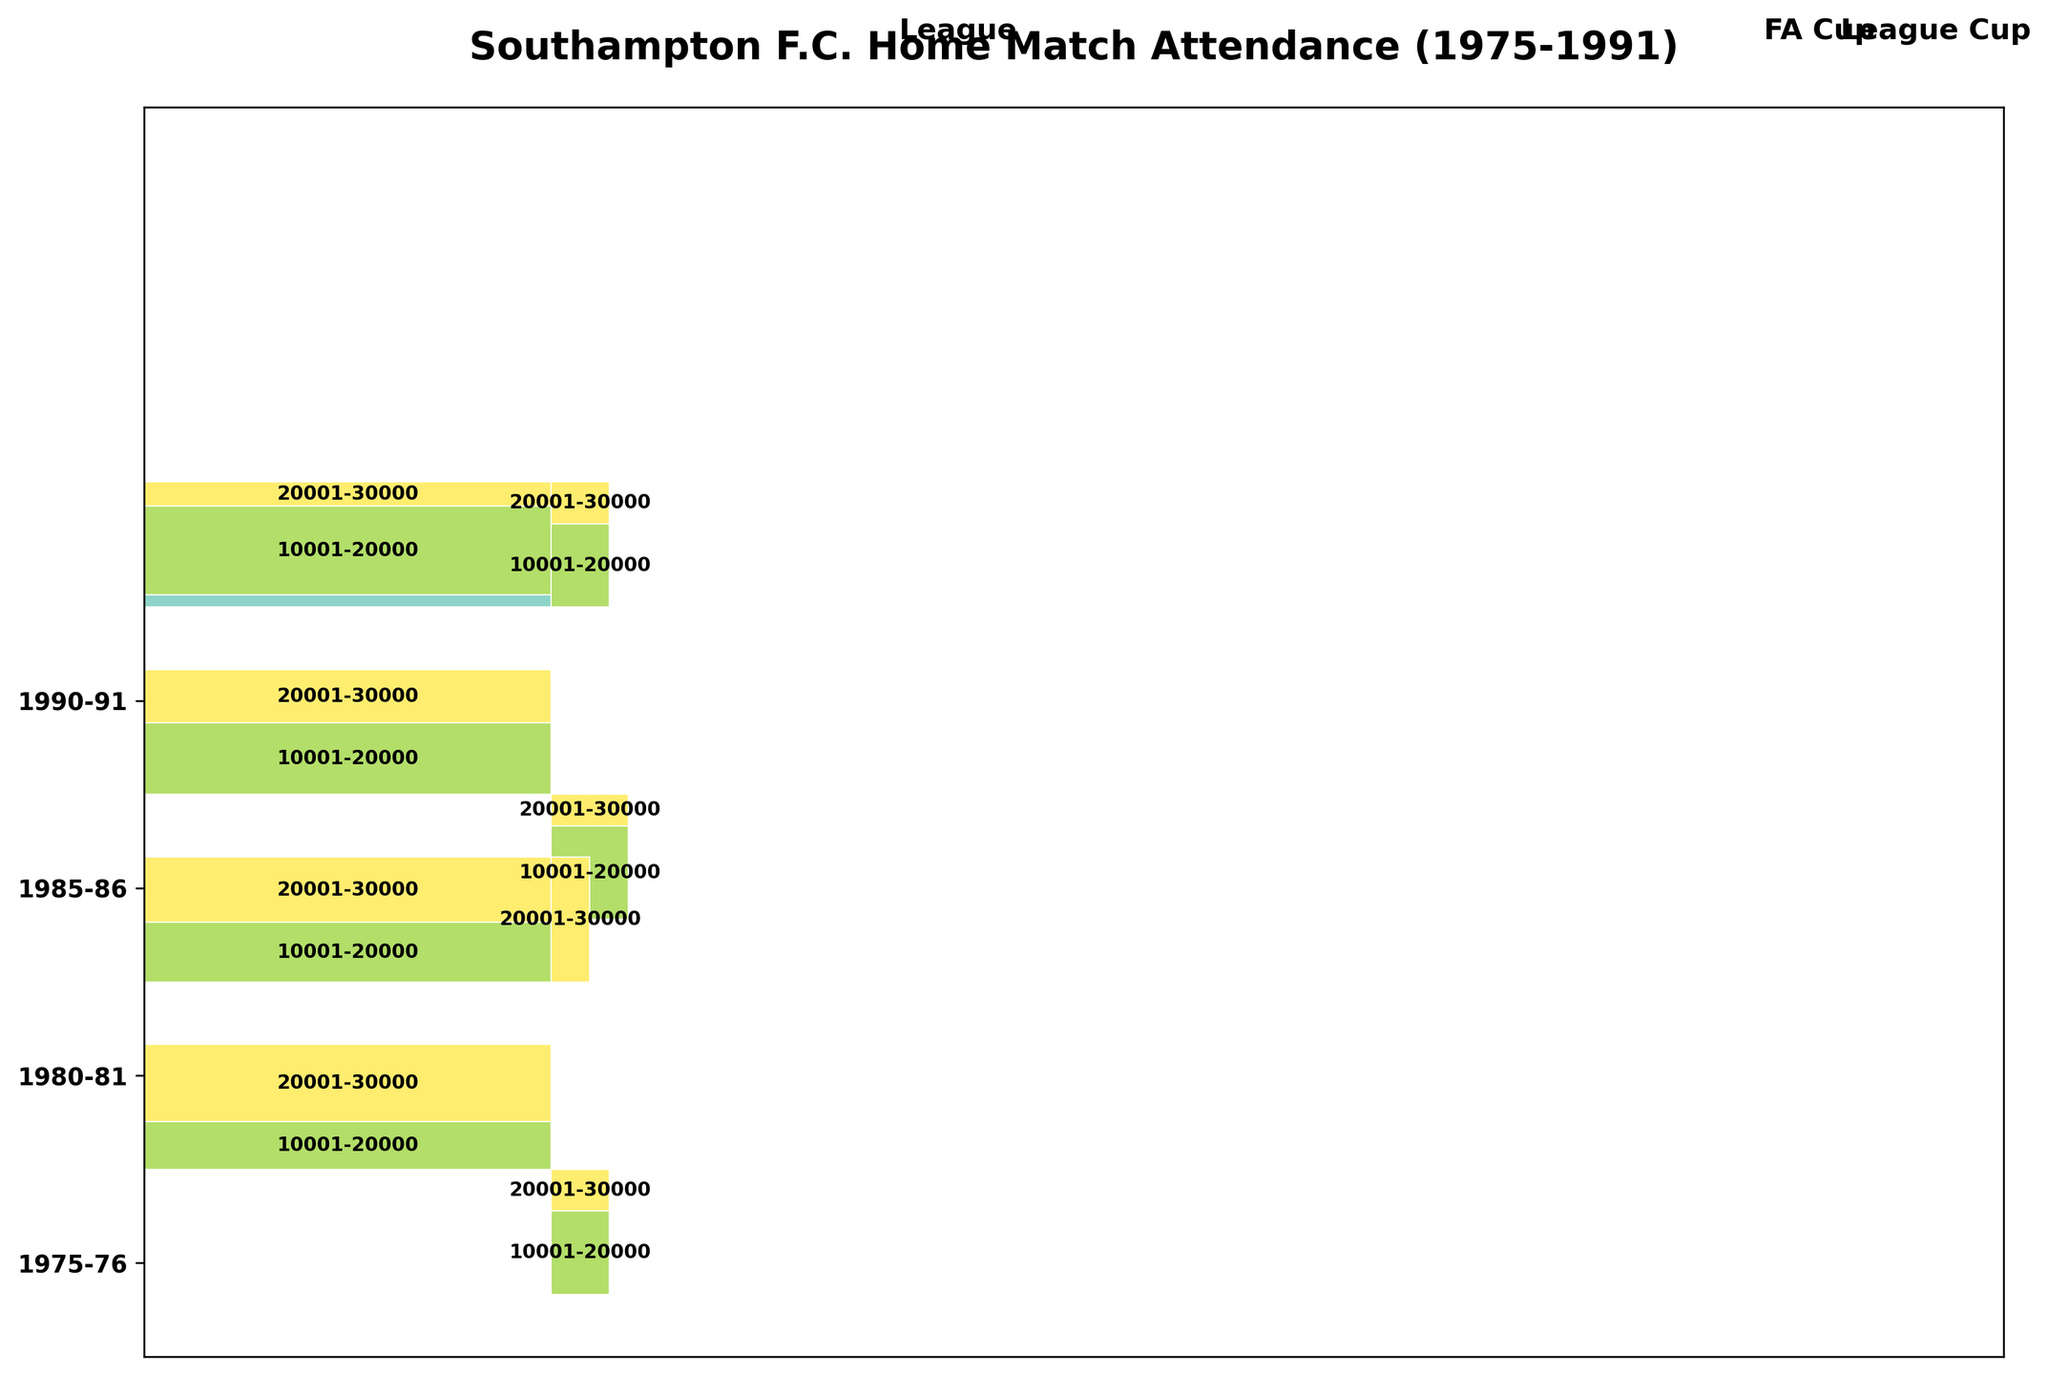What's the title of the Mosaic Plot? The title is usually positioned at the top of the figure. It provides an overview of the plot. By looking at the top of the plot, we can see the title clearly printed.
Answer: Southampton F.C. Home Match Attendance (1975-1991) Which season has the highest total match count? To identify the season with the highest total match count, you need to sum the counts of all attendance categories for each season. By comparing these sums across all seasons, we find the season with the highest value.
Answer: 1990-91 How many League matches had an attendance of 20,001-30,000 in the 1985-86 season? Look at the segment marked for the 1985-86 season and then focus on the League competition. Identify the rectangle that represents the 20,001-30,000 attendance category and refer to its count.
Answer: 11 Which competition type has the least representation in the 1980-81 season? Examine the 1980-81 season section and compare the width (representation) of each competition type. The one with the smallest width is the least represented.
Answer: League Cup Compare the attendance of FA Cup matches in the 1975-76 and 1985-86 seasons. Which one had higher total attendance? First, focus on the FA Cup rectangles for both seasons. Then sum up the counts for all attendance categories in the FA Cup portion of each season. Compare the total counts to determine which one is higher.
Answer: 1985-86 In which competition and season did the fewest matches occur? To determine this, look at all the rectangles and identify the smallest one in terms of height and width. This represents the fewest number of matches.
Answer: FA Cup in 1975-76 Which season saw the highest attendance in League Cup matches? Focus on the League Cup matches' sections across all seasons and identify which season has the tallest combined rectangles signifying the highest attendance.
Answer: 1980-81 What is the most common attendance category for League matches in the 1990-91 season? Look at the League matches section of the 1990-91 season and observe the different attendance categories. Identify the category with the highest count (tallest rectangle).
Answer: 20,001-30,000 How does the distribution of attendance in the League for the 1975-76 season compare to that in the 1980-81 season? Examine the League section for both seasons. Observe how the counts are distributed among the attendance categories in each season to compare their patterns.
Answer: 1975-76: More matches in 10,001-20,000; 1980-81: Balanced between 10,001-20,000 and 20,001-30,000 Did any season have an attendance category of 0-10,000 for League matches, and if so, which one? Scan through the League sections for all seasons. Identify if any season has a rectangle labeled 0-10,000 and note the season.
Answer: 1975-76 